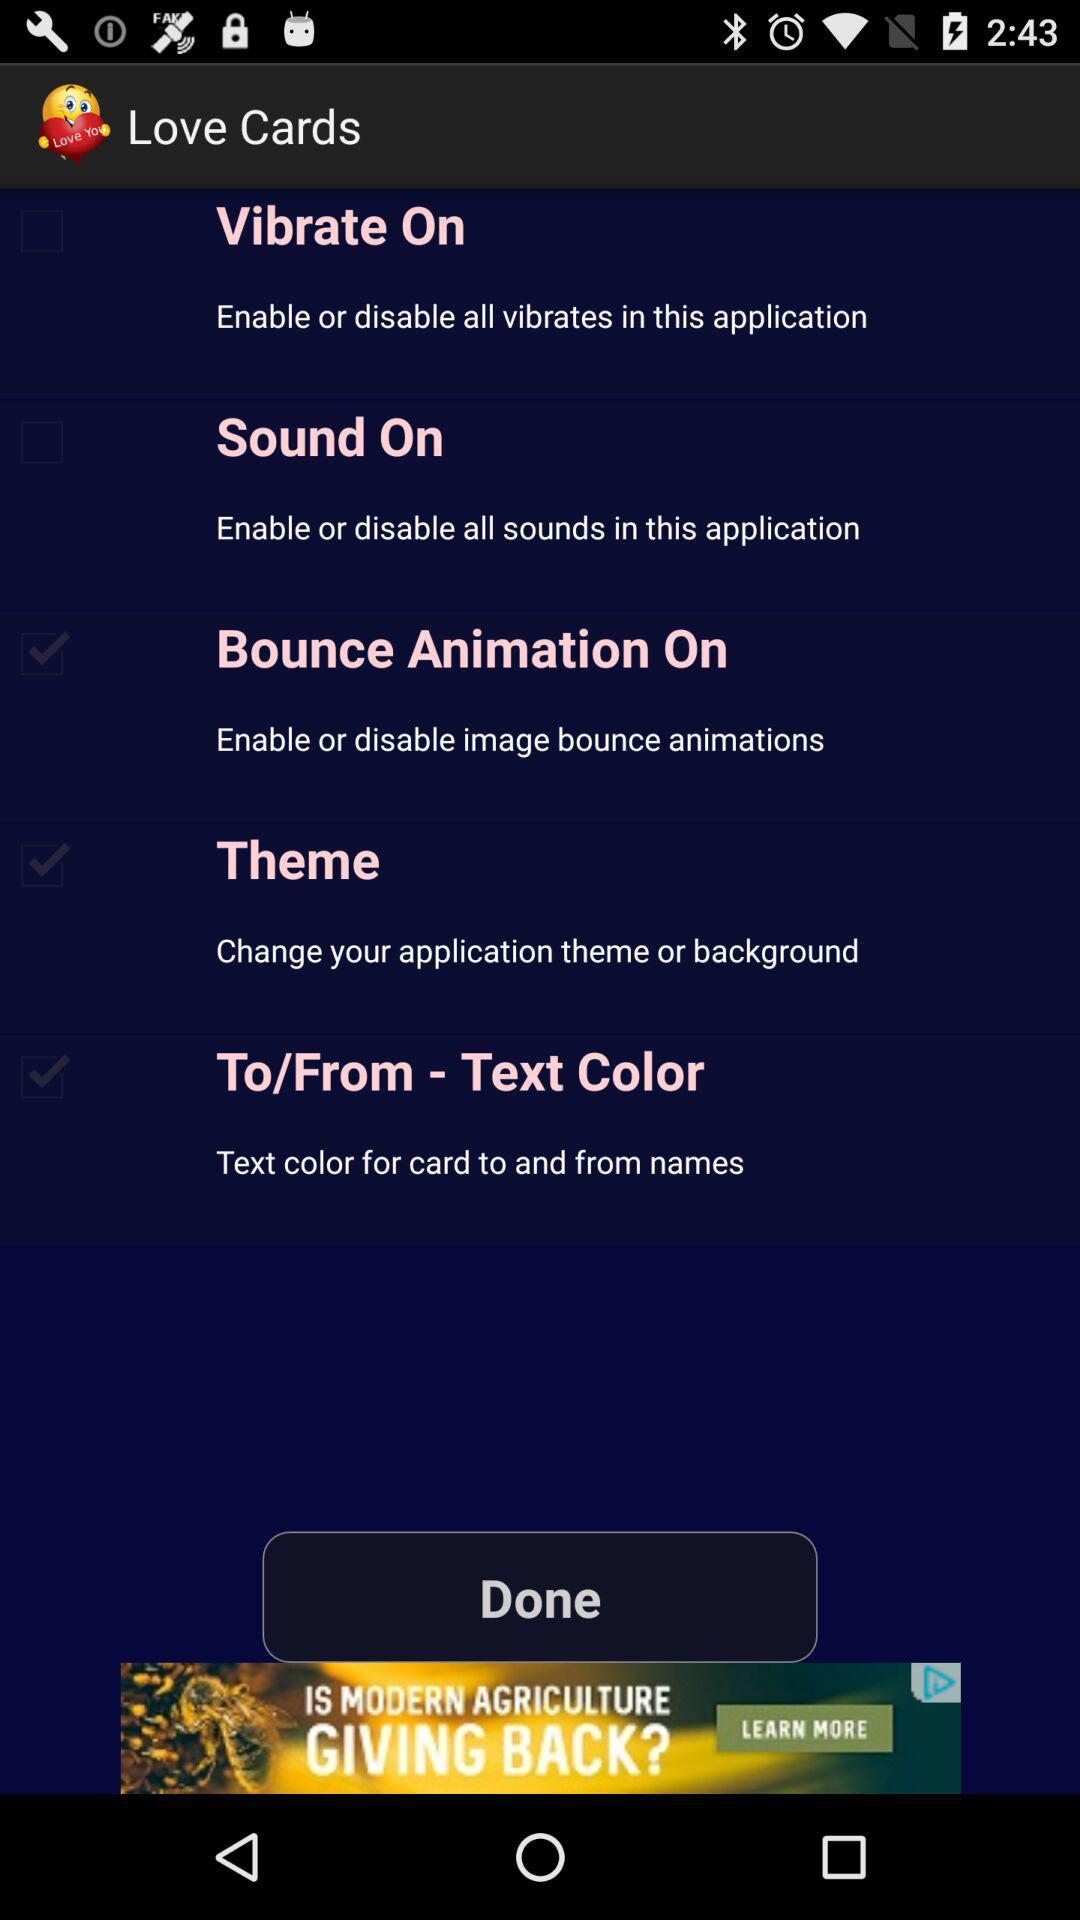What is the status of "Vibrate On"? The status is "off". 